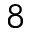Convert formula to latex. <formula><loc_0><loc_0><loc_500><loc_500>^ { 8 }</formula> 